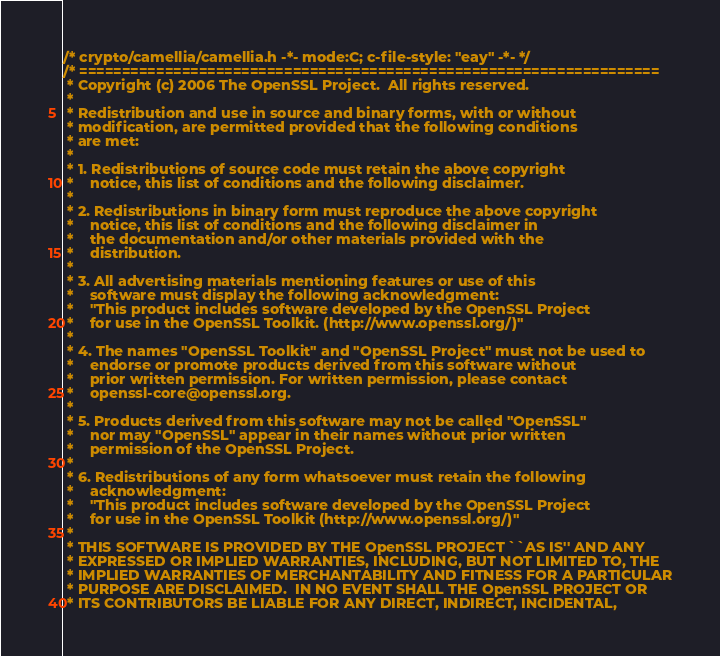Convert code to text. <code><loc_0><loc_0><loc_500><loc_500><_C_>/* crypto/camellia/camellia.h -*- mode:C; c-file-style: "eay" -*- */
/* ====================================================================
 * Copyright (c) 2006 The OpenSSL Project.  All rights reserved.
 *
 * Redistribution and use in source and binary forms, with or without
 * modification, are permitted provided that the following conditions
 * are met:
 *
 * 1. Redistributions of source code must retain the above copyright
 *    notice, this list of conditions and the following disclaimer. 
 *
 * 2. Redistributions in binary form must reproduce the above copyright
 *    notice, this list of conditions and the following disclaimer in
 *    the documentation and/or other materials provided with the
 *    distribution.
 *
 * 3. All advertising materials mentioning features or use of this
 *    software must display the following acknowledgment:
 *    "This product includes software developed by the OpenSSL Project
 *    for use in the OpenSSL Toolkit. (http://www.openssl.org/)"
 *
 * 4. The names "OpenSSL Toolkit" and "OpenSSL Project" must not be used to
 *    endorse or promote products derived from this software without
 *    prior written permission. For written permission, please contact
 *    openssl-core@openssl.org.
 *
 * 5. Products derived from this software may not be called "OpenSSL"
 *    nor may "OpenSSL" appear in their names without prior written
 *    permission of the OpenSSL Project.
 *
 * 6. Redistributions of any form whatsoever must retain the following
 *    acknowledgment:
 *    "This product includes software developed by the OpenSSL Project
 *    for use in the OpenSSL Toolkit (http://www.openssl.org/)"
 *
 * THIS SOFTWARE IS PROVIDED BY THE OpenSSL PROJECT ``AS IS'' AND ANY
 * EXPRESSED OR IMPLIED WARRANTIES, INCLUDING, BUT NOT LIMITED TO, THE
 * IMPLIED WARRANTIES OF MERCHANTABILITY AND FITNESS FOR A PARTICULAR
 * PURPOSE ARE DISCLAIMED.  IN NO EVENT SHALL THE OpenSSL PROJECT OR
 * ITS CONTRIBUTORS BE LIABLE FOR ANY DIRECT, INDIRECT, INCIDENTAL,</code> 